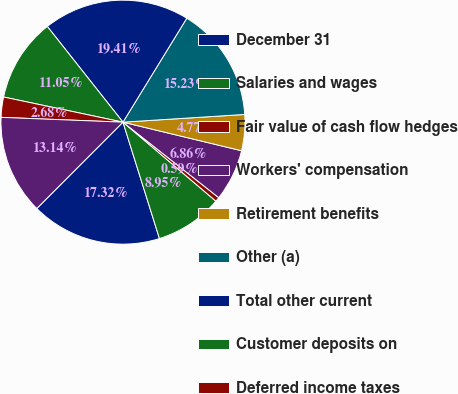Convert chart to OTSL. <chart><loc_0><loc_0><loc_500><loc_500><pie_chart><fcel>December 31<fcel>Salaries and wages<fcel>Fair value of cash flow hedges<fcel>Workers' compensation<fcel>Retirement benefits<fcel>Other (a)<fcel>Total other current<fcel>Customer deposits on<fcel>Deferred income taxes<fcel>Other (b)<nl><fcel>17.32%<fcel>8.95%<fcel>0.59%<fcel>6.86%<fcel>4.77%<fcel>15.23%<fcel>19.41%<fcel>11.05%<fcel>2.68%<fcel>13.14%<nl></chart> 